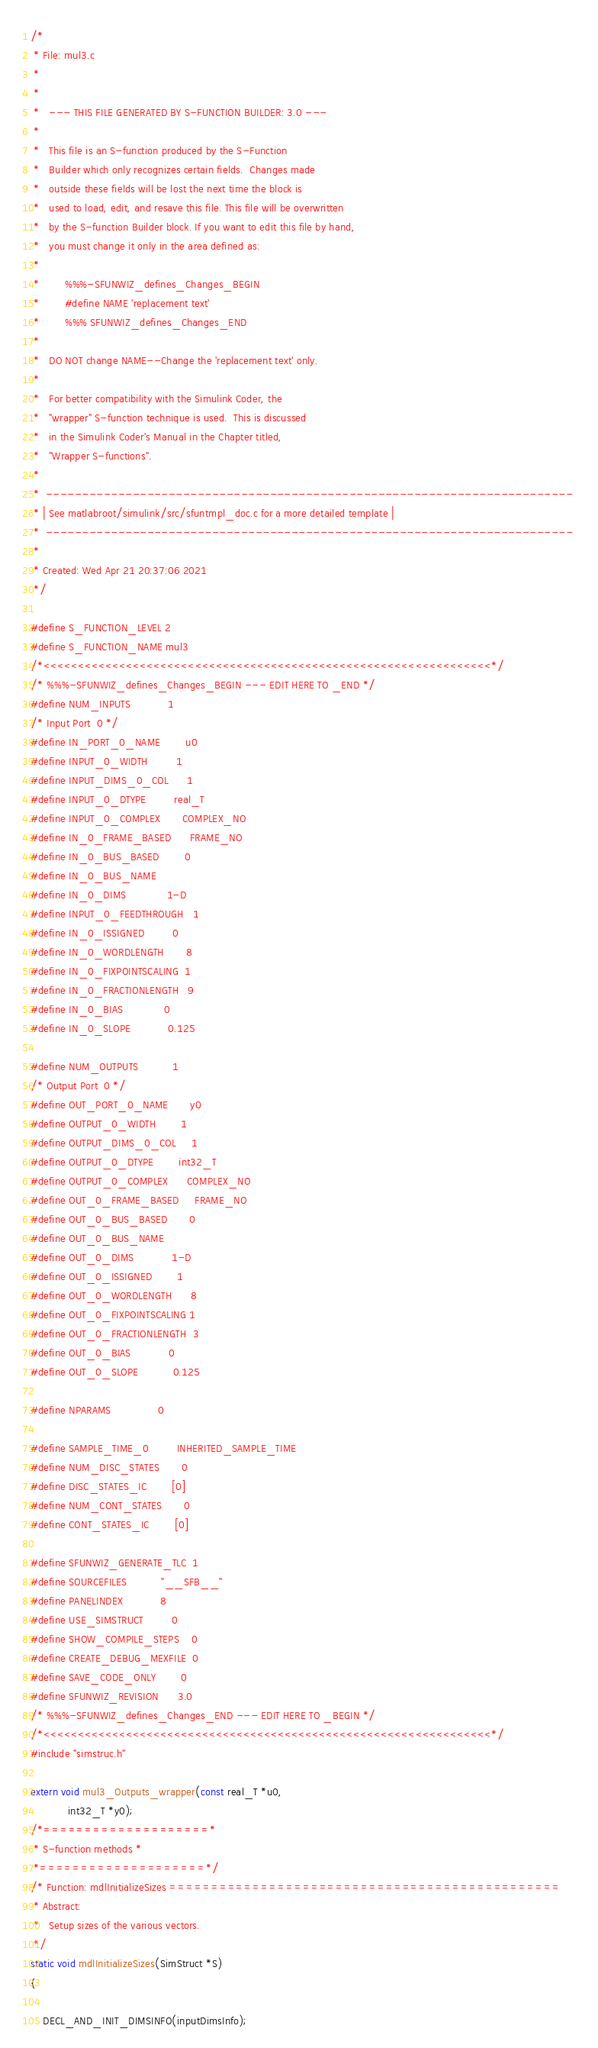<code> <loc_0><loc_0><loc_500><loc_500><_C_>/*
 * File: mul3.c
 *
 *
 *   --- THIS FILE GENERATED BY S-FUNCTION BUILDER: 3.0 ---
 *
 *   This file is an S-function produced by the S-Function
 *   Builder which only recognizes certain fields.  Changes made
 *   outside these fields will be lost the next time the block is
 *   used to load, edit, and resave this file. This file will be overwritten
 *   by the S-function Builder block. If you want to edit this file by hand, 
 *   you must change it only in the area defined as:  
 *
 *        %%%-SFUNWIZ_defines_Changes_BEGIN
 *        #define NAME 'replacement text' 
 *        %%% SFUNWIZ_defines_Changes_END
 *
 *   DO NOT change NAME--Change the 'replacement text' only.
 *
 *   For better compatibility with the Simulink Coder, the
 *   "wrapper" S-function technique is used.  This is discussed
 *   in the Simulink Coder's Manual in the Chapter titled,
 *   "Wrapper S-functions".
 *
 *  -------------------------------------------------------------------------
 * | See matlabroot/simulink/src/sfuntmpl_doc.c for a more detailed template |
 *  ------------------------------------------------------------------------- 
 *
 * Created: Wed Apr 21 20:37:06 2021
 */

#define S_FUNCTION_LEVEL 2
#define S_FUNCTION_NAME mul3
/*<<<<<<<<<<<<<<<<<<<<<<<<<<<<<<<<<<<<<<<<<<<<<<<<<<<<<<<<<<<<<<<<<*/
/* %%%-SFUNWIZ_defines_Changes_BEGIN --- EDIT HERE TO _END */
#define NUM_INPUTS            1
/* Input Port  0 */
#define IN_PORT_0_NAME        u0
#define INPUT_0_WIDTH         1
#define INPUT_DIMS_0_COL      1
#define INPUT_0_DTYPE         real_T
#define INPUT_0_COMPLEX       COMPLEX_NO
#define IN_0_FRAME_BASED      FRAME_NO
#define IN_0_BUS_BASED        0
#define IN_0_BUS_NAME         
#define IN_0_DIMS             1-D
#define INPUT_0_FEEDTHROUGH   1
#define IN_0_ISSIGNED         0
#define IN_0_WORDLENGTH       8
#define IN_0_FIXPOINTSCALING  1
#define IN_0_FRACTIONLENGTH   9
#define IN_0_BIAS             0
#define IN_0_SLOPE            0.125

#define NUM_OUTPUTS           1
/* Output Port  0 */
#define OUT_PORT_0_NAME       y0
#define OUTPUT_0_WIDTH        1
#define OUTPUT_DIMS_0_COL     1
#define OUTPUT_0_DTYPE        int32_T
#define OUTPUT_0_COMPLEX      COMPLEX_NO
#define OUT_0_FRAME_BASED     FRAME_NO
#define OUT_0_BUS_BASED       0
#define OUT_0_BUS_NAME        
#define OUT_0_DIMS            1-D
#define OUT_0_ISSIGNED        1
#define OUT_0_WORDLENGTH      8
#define OUT_0_FIXPOINTSCALING 1
#define OUT_0_FRACTIONLENGTH  3
#define OUT_0_BIAS            0
#define OUT_0_SLOPE           0.125

#define NPARAMS               0

#define SAMPLE_TIME_0         INHERITED_SAMPLE_TIME
#define NUM_DISC_STATES       0
#define DISC_STATES_IC        [0]
#define NUM_CONT_STATES       0
#define CONT_STATES_IC        [0]

#define SFUNWIZ_GENERATE_TLC  1
#define SOURCEFILES           "__SFB__"
#define PANELINDEX            8
#define USE_SIMSTRUCT         0
#define SHOW_COMPILE_STEPS    0
#define CREATE_DEBUG_MEXFILE  0
#define SAVE_CODE_ONLY        0
#define SFUNWIZ_REVISION      3.0
/* %%%-SFUNWIZ_defines_Changes_END --- EDIT HERE TO _BEGIN */
/*<<<<<<<<<<<<<<<<<<<<<<<<<<<<<<<<<<<<<<<<<<<<<<<<<<<<<<<<<<<<<<<<<*/
#include "simstruc.h"

extern void mul3_Outputs_wrapper(const real_T *u0,
			int32_T *y0);
/*====================*
 * S-function methods *
 *====================*/
/* Function: mdlInitializeSizes ===============================================
 * Abstract:
 *   Setup sizes of the various vectors.
 */
static void mdlInitializeSizes(SimStruct *S)
{

    DECL_AND_INIT_DIMSINFO(inputDimsInfo);</code> 